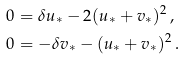<formula> <loc_0><loc_0><loc_500><loc_500>0 & = \delta u _ { * } - 2 ( u _ { * } + v _ { * } ) ^ { 2 } \, , \\ 0 & = - \delta v _ { * } - ( u _ { * } + v _ { * } ) ^ { 2 } \, .</formula> 